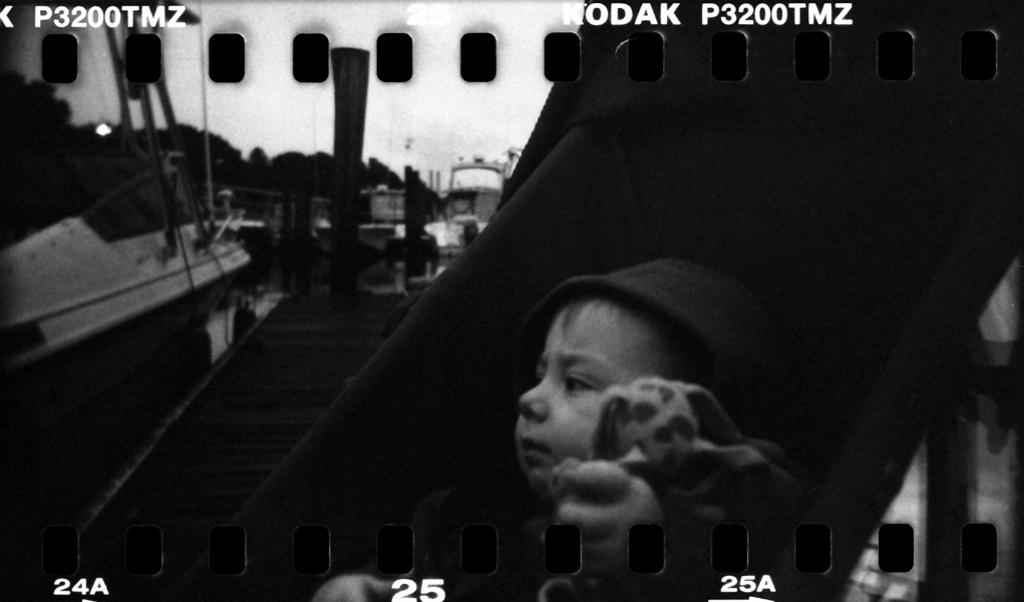What is the main subject of the image? There is a child in the image. What is the child wearing on their head? The child is wearing a cap. What other item can be seen in the image besides the child? There is a toy in the image. What can be seen in the background of the image? There is a boat and other objects visible in the background of the image. What type of lettuce is being used as a surprise prop in the image? There is no lettuce or surprise prop present in the image. 